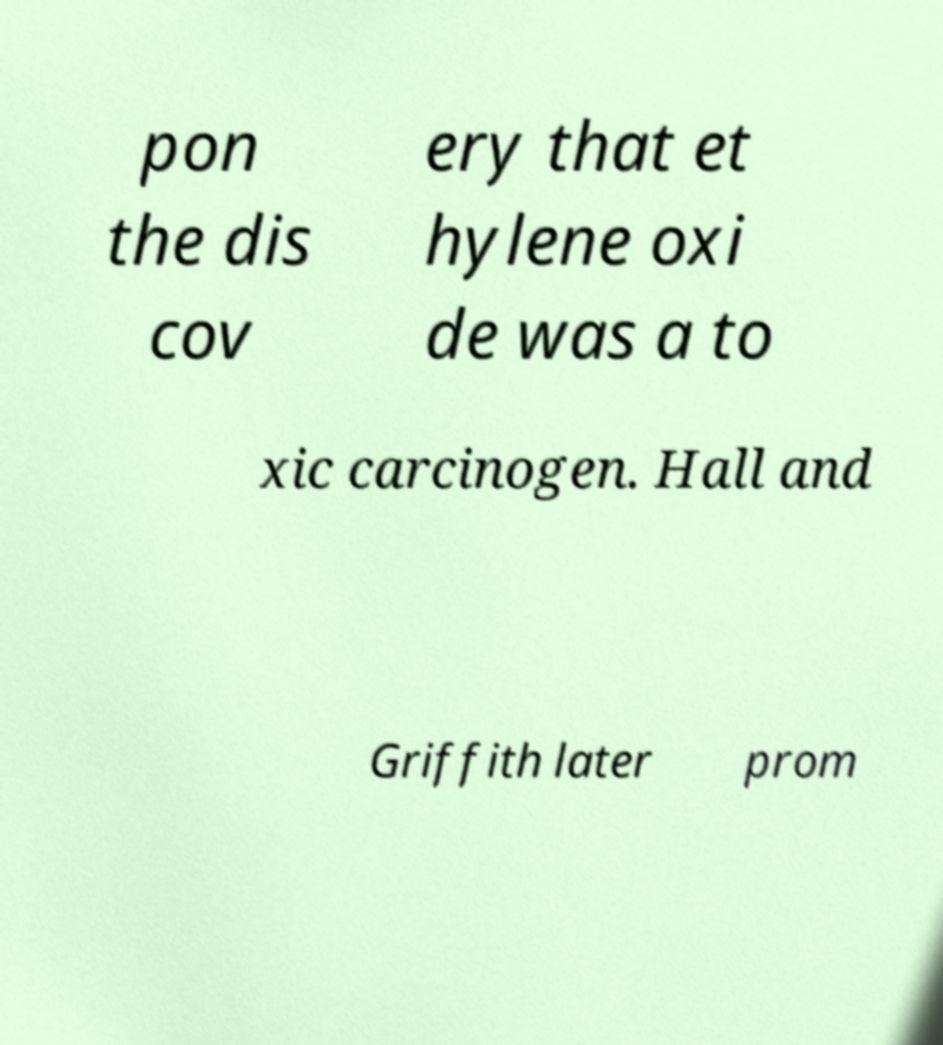Please read and relay the text visible in this image. What does it say? pon the dis cov ery that et hylene oxi de was a to xic carcinogen. Hall and Griffith later prom 